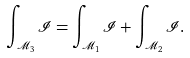Convert formula to latex. <formula><loc_0><loc_0><loc_500><loc_500>\int _ { \mathcal { M } _ { 3 } } \mathcal { I } = \int _ { \mathcal { M } _ { 1 } } \mathcal { I } + \int _ { \mathcal { M } _ { 2 } } \mathcal { I } .</formula> 